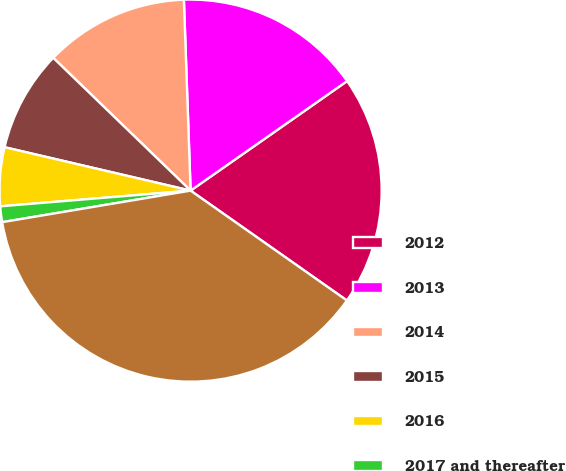Convert chart to OTSL. <chart><loc_0><loc_0><loc_500><loc_500><pie_chart><fcel>2012<fcel>2013<fcel>2014<fcel>2015<fcel>2016<fcel>2017 and thereafter<fcel>Total<nl><fcel>19.47%<fcel>15.84%<fcel>12.21%<fcel>8.58%<fcel>4.96%<fcel>1.33%<fcel>37.61%<nl></chart> 